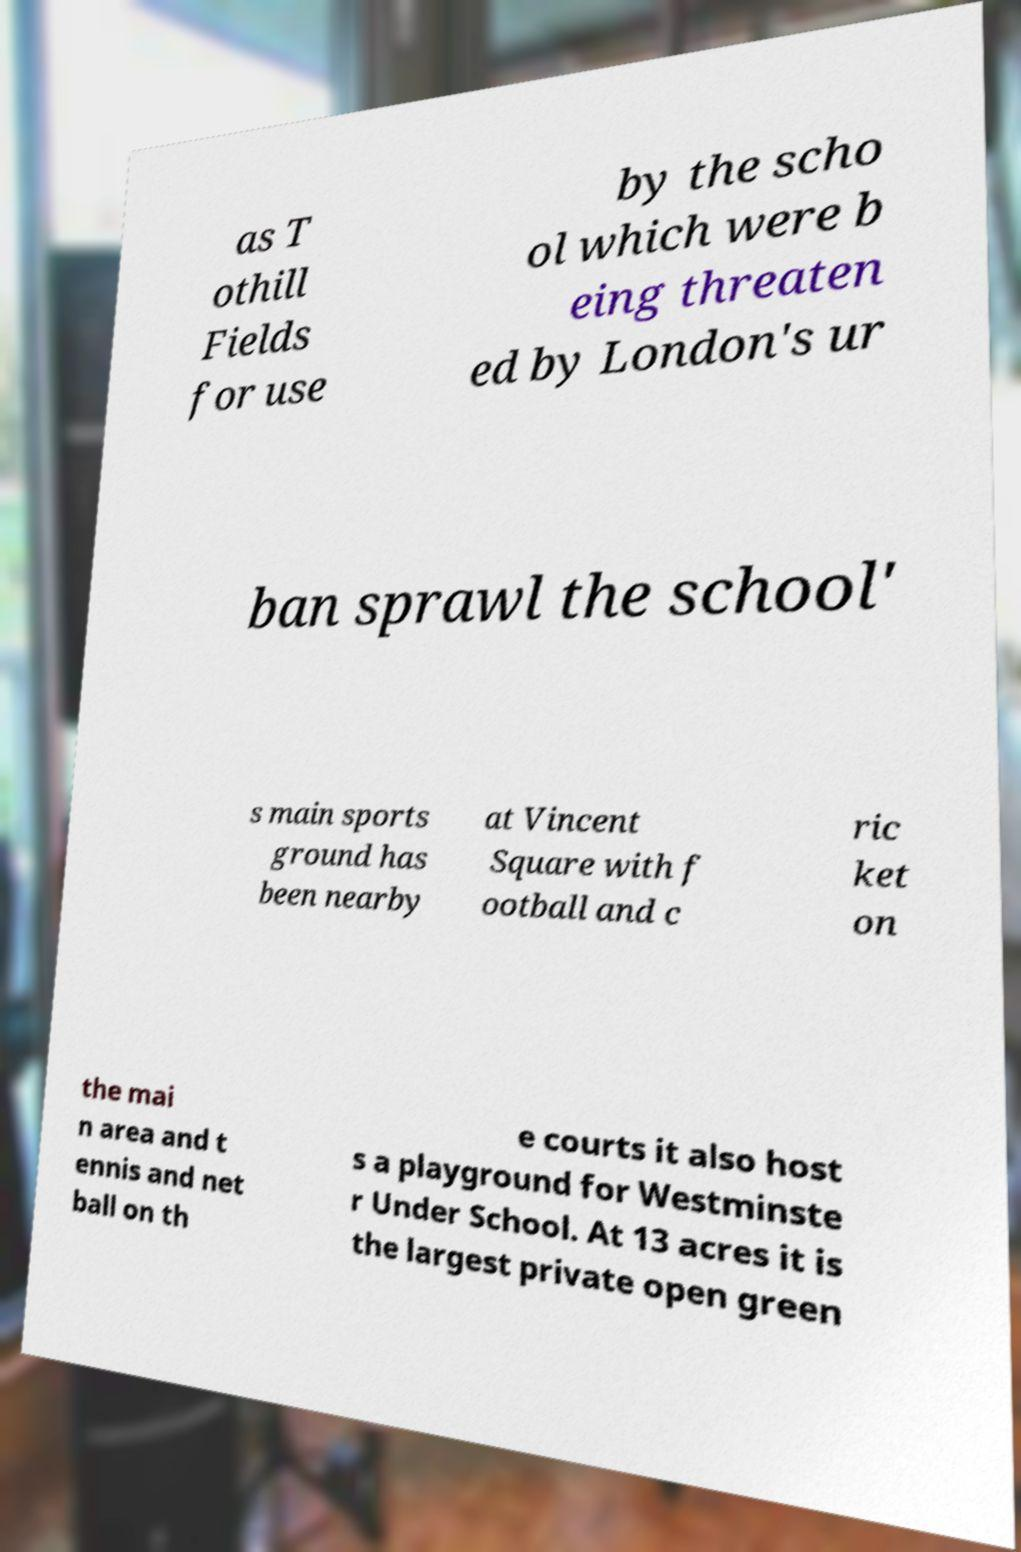What messages or text are displayed in this image? I need them in a readable, typed format. as T othill Fields for use by the scho ol which were b eing threaten ed by London's ur ban sprawl the school' s main sports ground has been nearby at Vincent Square with f ootball and c ric ket on the mai n area and t ennis and net ball on th e courts it also host s a playground for Westminste r Under School. At 13 acres it is the largest private open green 